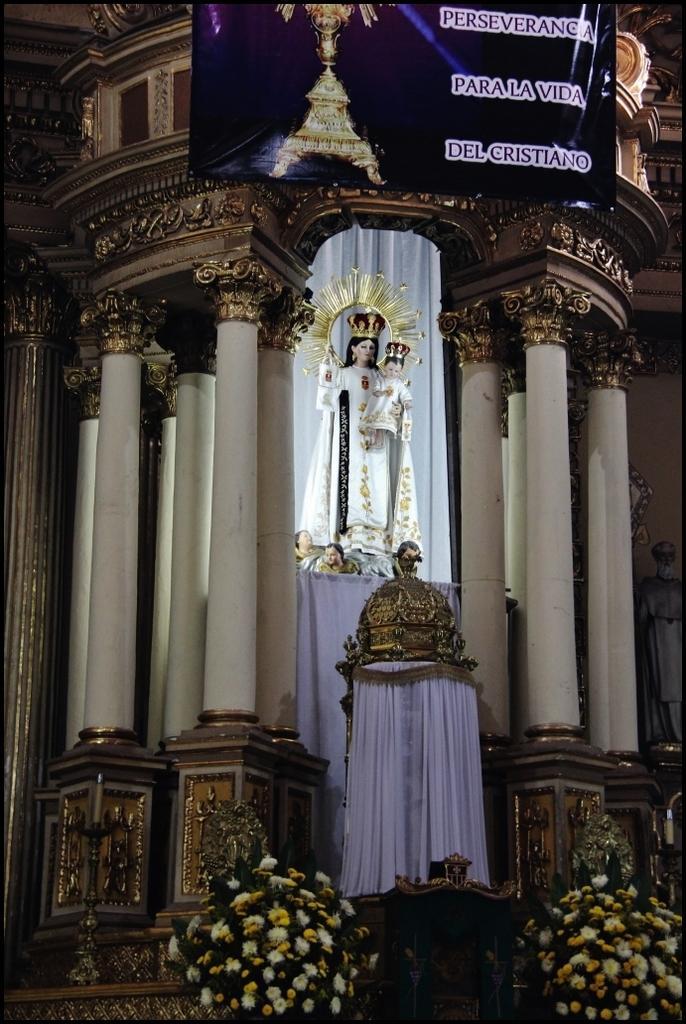Can you describe this image briefly? This picture might be taken in a church, in this picture in the center there is one statue and some curtains. On the top of the image there is one poster, and on the right side there is one statue and in the center there are some pillars. At the bottom there are two flower bouquets. 